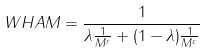Convert formula to latex. <formula><loc_0><loc_0><loc_500><loc_500>W H A M = \frac { 1 } { \lambda \frac { 1 } { M ^ { r } } + ( 1 - \lambda ) \frac { 1 } { M ^ { c } } }</formula> 